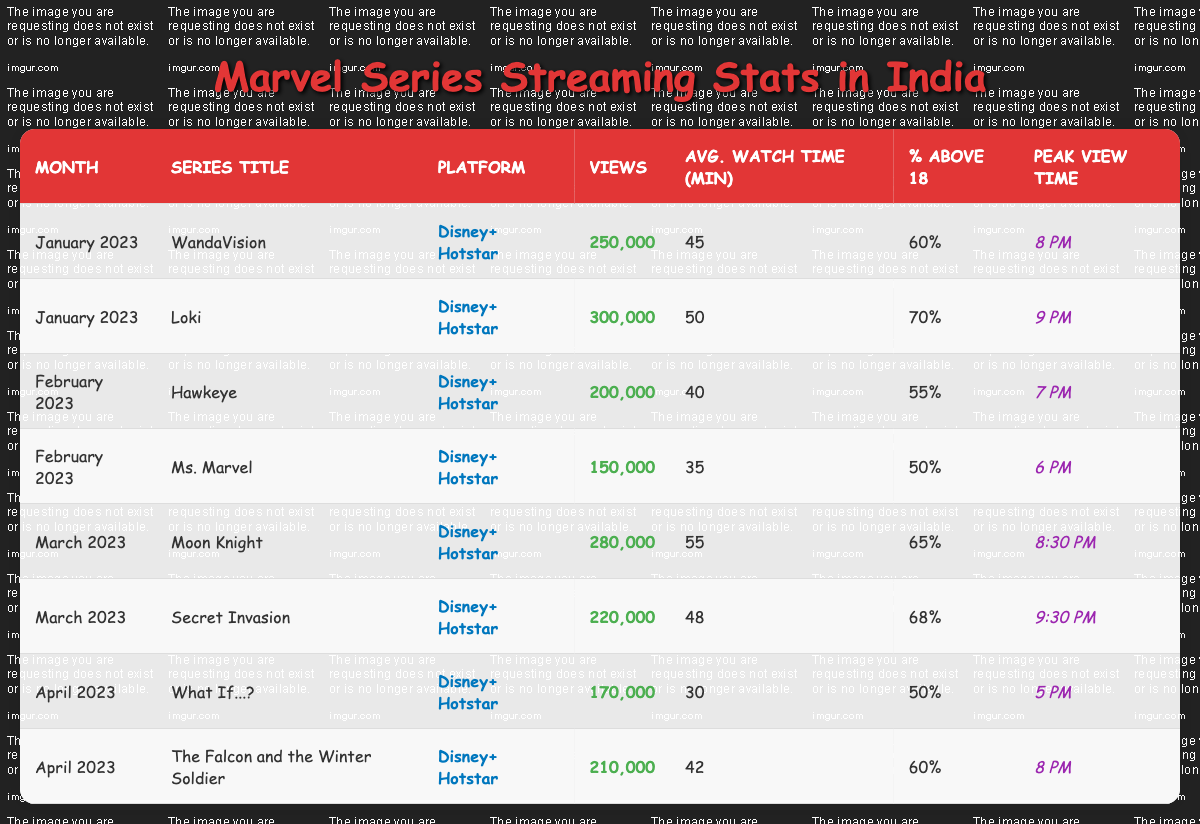What was the total number of views for the Marvel series in January 2023? In January 2023, there were two series: "WandaVision" with 250,000 views and "Loki" with 300,000 views. Adding these together gives 250,000 + 300,000 = 550,000 views.
Answer: 550,000 Which Marvel series had the highest average watch time in February 2023? In February 2023, "Hawkeye" had an average watch time of 40 minutes and "Ms. Marvel" had 35 minutes. Comparing these values, "Hawkeye" has the higher average watch time.
Answer: Hawkeye True or False: The percentage of viewers above 18 for "Moon Knight" was less than 70%. The percentage of viewers above 18 for "Moon Knight" is 65%, which is indeed less than 70%. Thus, the statement is true.
Answer: True What is the peak view time for "The Falcon and the Winter Soldier"? The peak view time for "The Falcon and the Winter Soldier" is listed in the table as 8 PM.
Answer: 8 PM How many series had more than 250,000 views in March 2023? In March 2023, "Moon Knight" had 280,000 views and "Secret Invasion" had 220,000 views. Since only "Moon Knight" exceeds 250,000 views, the count is 1 series.
Answer: 1 Which two series had a higher percentage of viewers above 18 than "Hawkeye"? The percentage of viewers above 18 for "Hawkeye" is 55%. "Loki" had 70% and "Secret Invasion" had 68%, both of which are higher than 55%. Therefore, "Loki" and "Secret Invasion" meet the criteria.
Answer: Loki and Secret Invasion What was the average watch time of all Marvel series in April 2023? In April 2023, "What If...?" had an average watch time of 30 minutes and "The Falcon and the Winter Soldier" had 42 minutes. Add both: 30 + 42 = 72 minutes, then divide by 2 for the average: 72 / 2 = 36 minutes.
Answer: 36 minutes Which series had the least number of views overall? Reviewing all the series, "Ms. Marvel" in February 2023 had the least views at 150,000.
Answer: Ms. Marvel How did the number of views for "Loki" compare to the views for "WandaVision"? "Loki" had 300,000 views while "WandaVision" had 250,000 views. Thus, "Loki" had 50,000 more views than "WandaVision".
Answer: 50,000 more views 